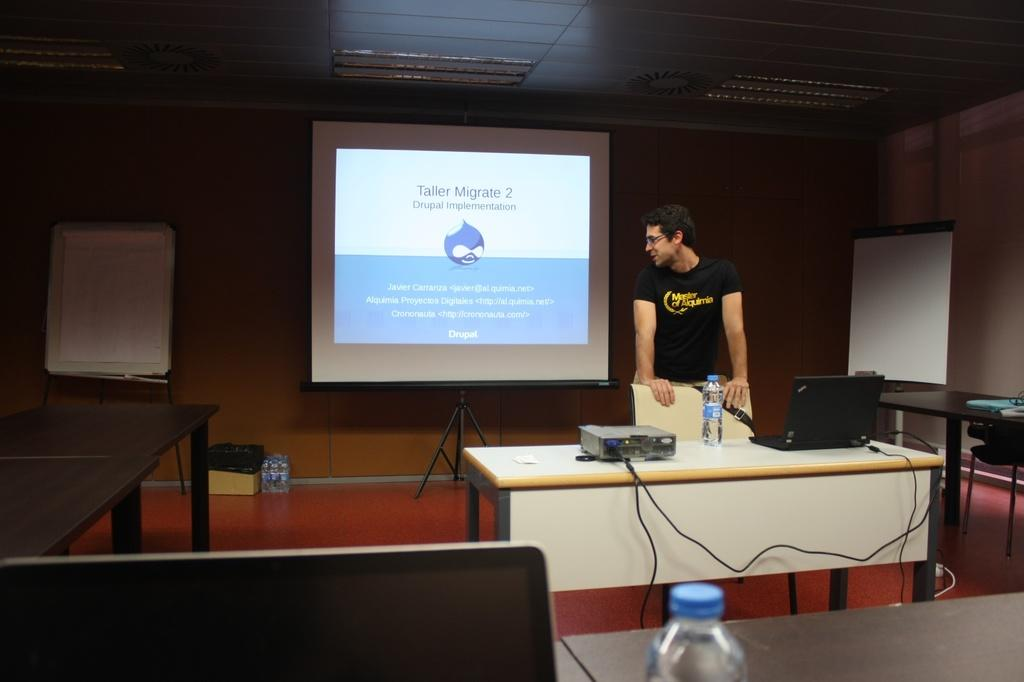What is the main subject in the image? There is a man standing in the image. What object is on the table in the image? A projector and a laptop are present on the table. What is the purpose of the projector in the image? The projector is likely used for displaying content on the projector screen. What can be seen behind the table in the image? There is a water bottle at the back of the table. What is the large, flat surface visible in the image? A projector screen is visible in the image. What type of art is being advertised on the yak in the image? There is no yak or art being advertised in the image; it features a man, a table, a projector, a laptop, a water bottle, and a projector screen. 